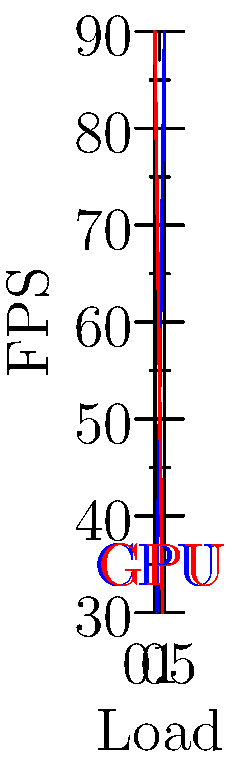In a real-time physics simulation for a game engine, the graph shows the relationship between CPU/GPU load balancing and frames per second (FPS). What is the optimal load distribution between CPU and GPU to achieve the highest FPS, and how might this impact the gaming experience for a tech-savvy player concerned with bug-free software? To answer this question, let's analyze the graph step-by-step:

1. The blue line represents the relationship between CPU load and FPS.
2. The red line represents the relationship between GPU load and FPS.
3. As we move from left to right on the x-axis, CPU load increases while GPU load decreases.
4. The y-axis shows the resulting FPS for each load distribution.

5. Observing the graph, we can see that the FPS peaks at the intersection of the CPU and GPU load lines.
6. This intersection occurs at approximately 0.5 (50%) load for both CPU and GPU.
7. At this point, the FPS reaches its maximum value of about 90.

8. For a tech-savvy gamer concerned with bug-free software:
   a. Optimal load balancing ensures smooth gameplay with high FPS.
   b. Even distribution of work between CPU and GPU reduces the likelihood of bottlenecks.
   c. Balanced load may lead to more stable performance and fewer crashes or glitches.
   d. It allows for more complex physics simulations without sacrificing frame rate.

9. The impact on gaming experience:
   a. Higher FPS contributes to more responsive controls and smoother animations.
   b. Balanced load allows for more consistent performance across different game scenarios.
   c. Reduced chance of frame drops or stuttering during intense physics calculations.
   d. Potentially lower heat generation and power consumption, leading to longer gaming sessions.

Therefore, the optimal load distribution is an even 50-50 split between CPU and GPU, resulting in the highest FPS and potentially the most stable, bug-free gaming experience.
Answer: 50-50 CPU-GPU load balance for maximum FPS and optimal gaming experience. 